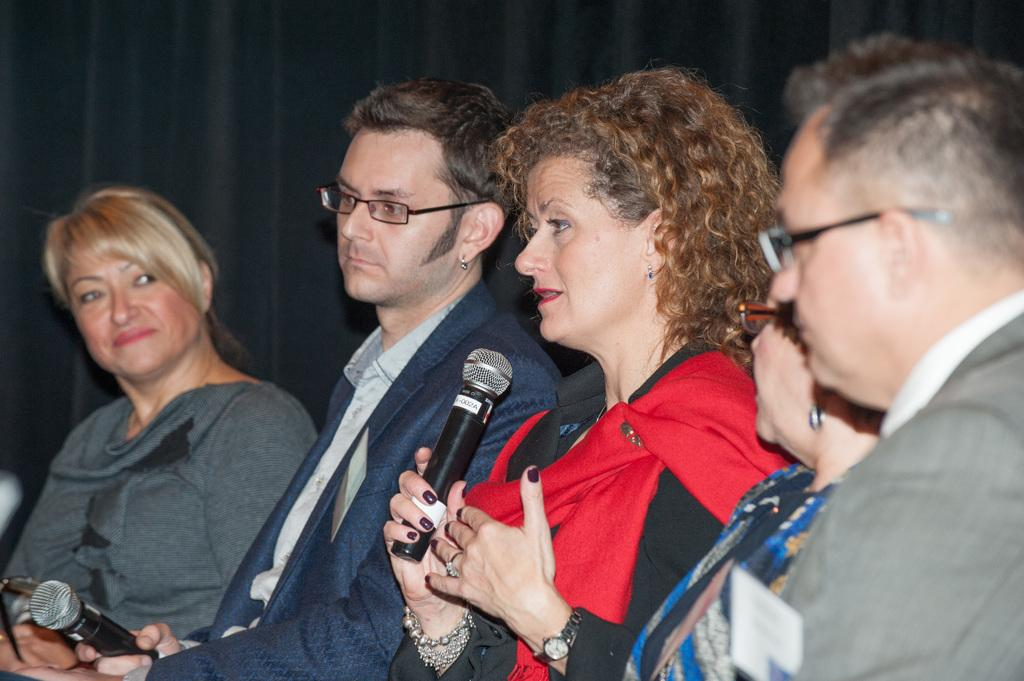How many people are in the image? There are five persons in the image. What can be observed about their clothing? The persons are wearing different color dresses. What are the persons doing in the image? The persons are sitting. Can you identify any specific action being performed by one of the persons? One of the persons is holding a mic and speaking. What is the color of the background in the image? The background of the image is dark in color. What type of amusement can be seen in the image? There is no amusement present in the image; it features five persons sitting and one holding a mic. Can you tell me how many bananas are being held by the person with the mic? There are no bananas visible in the image; the person with the mic is holding a mic and speaking. 